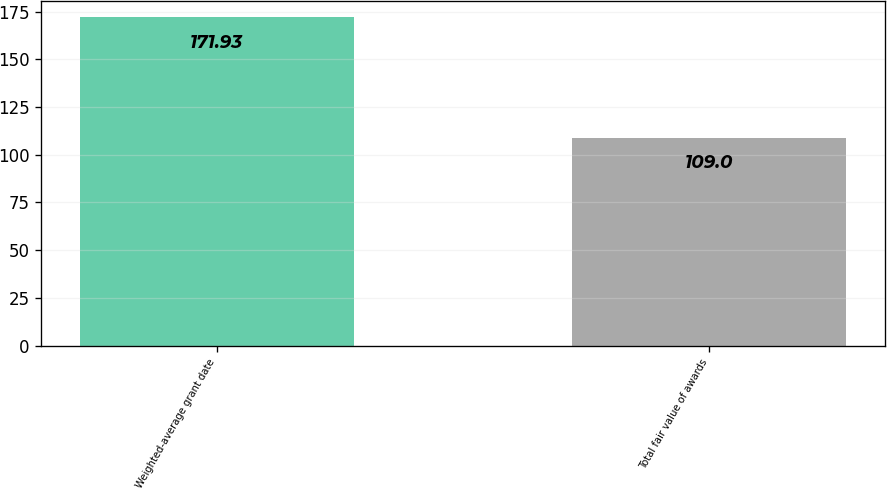Convert chart to OTSL. <chart><loc_0><loc_0><loc_500><loc_500><bar_chart><fcel>Weighted-average grant date<fcel>Total fair value of awards<nl><fcel>171.93<fcel>109<nl></chart> 